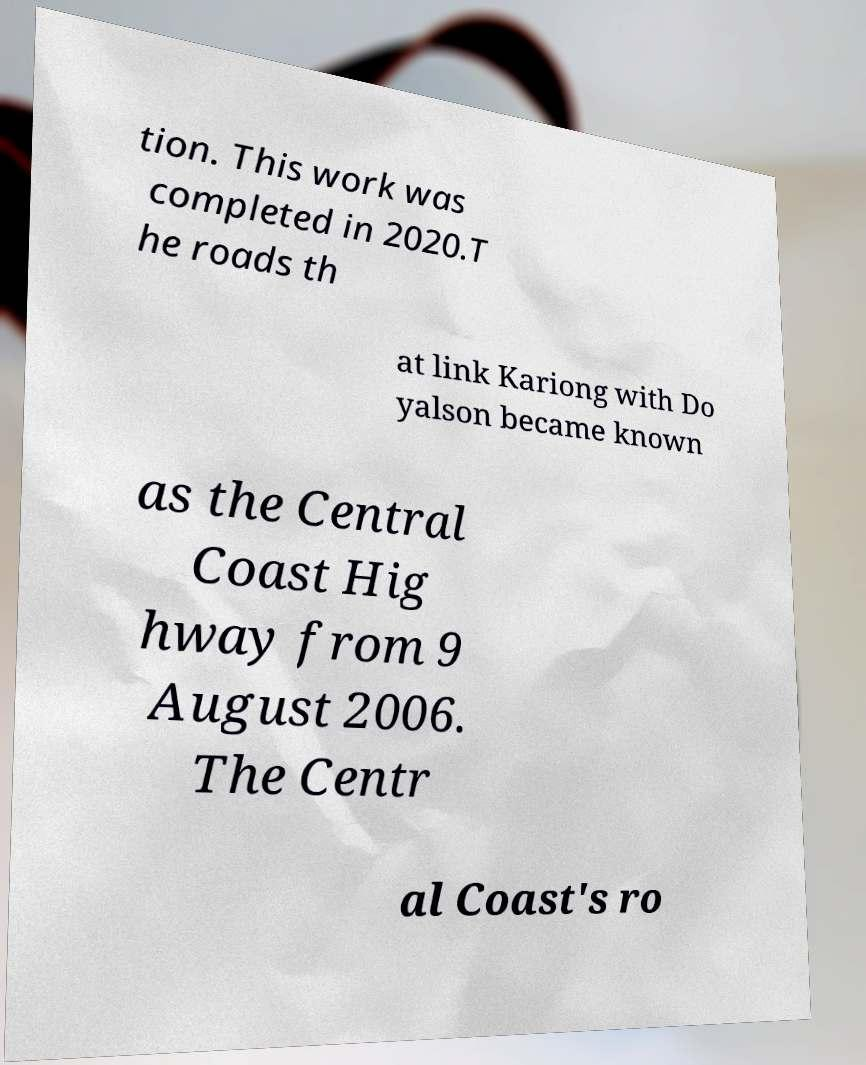Please read and relay the text visible in this image. What does it say? tion. This work was completed in 2020.T he roads th at link Kariong with Do yalson became known as the Central Coast Hig hway from 9 August 2006. The Centr al Coast's ro 